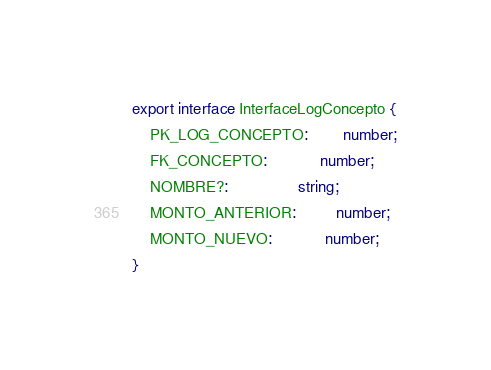Convert code to text. <code><loc_0><loc_0><loc_500><loc_500><_TypeScript_>export interface InterfaceLogConcepto {
    PK_LOG_CONCEPTO:        number;
    FK_CONCEPTO:            number;
    NOMBRE?:                string;
    MONTO_ANTERIOR:         number;
    MONTO_NUEVO:            number;
}
</code> 